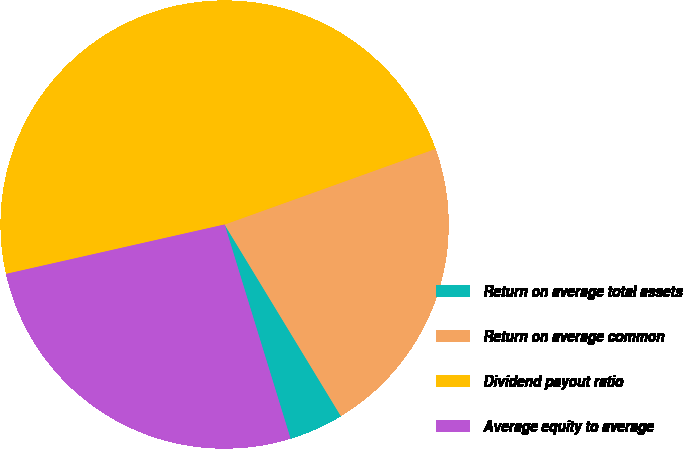<chart> <loc_0><loc_0><loc_500><loc_500><pie_chart><fcel>Return on average total assets<fcel>Return on average common<fcel>Dividend payout ratio<fcel>Average equity to average<nl><fcel>3.93%<fcel>21.8%<fcel>48.05%<fcel>26.21%<nl></chart> 